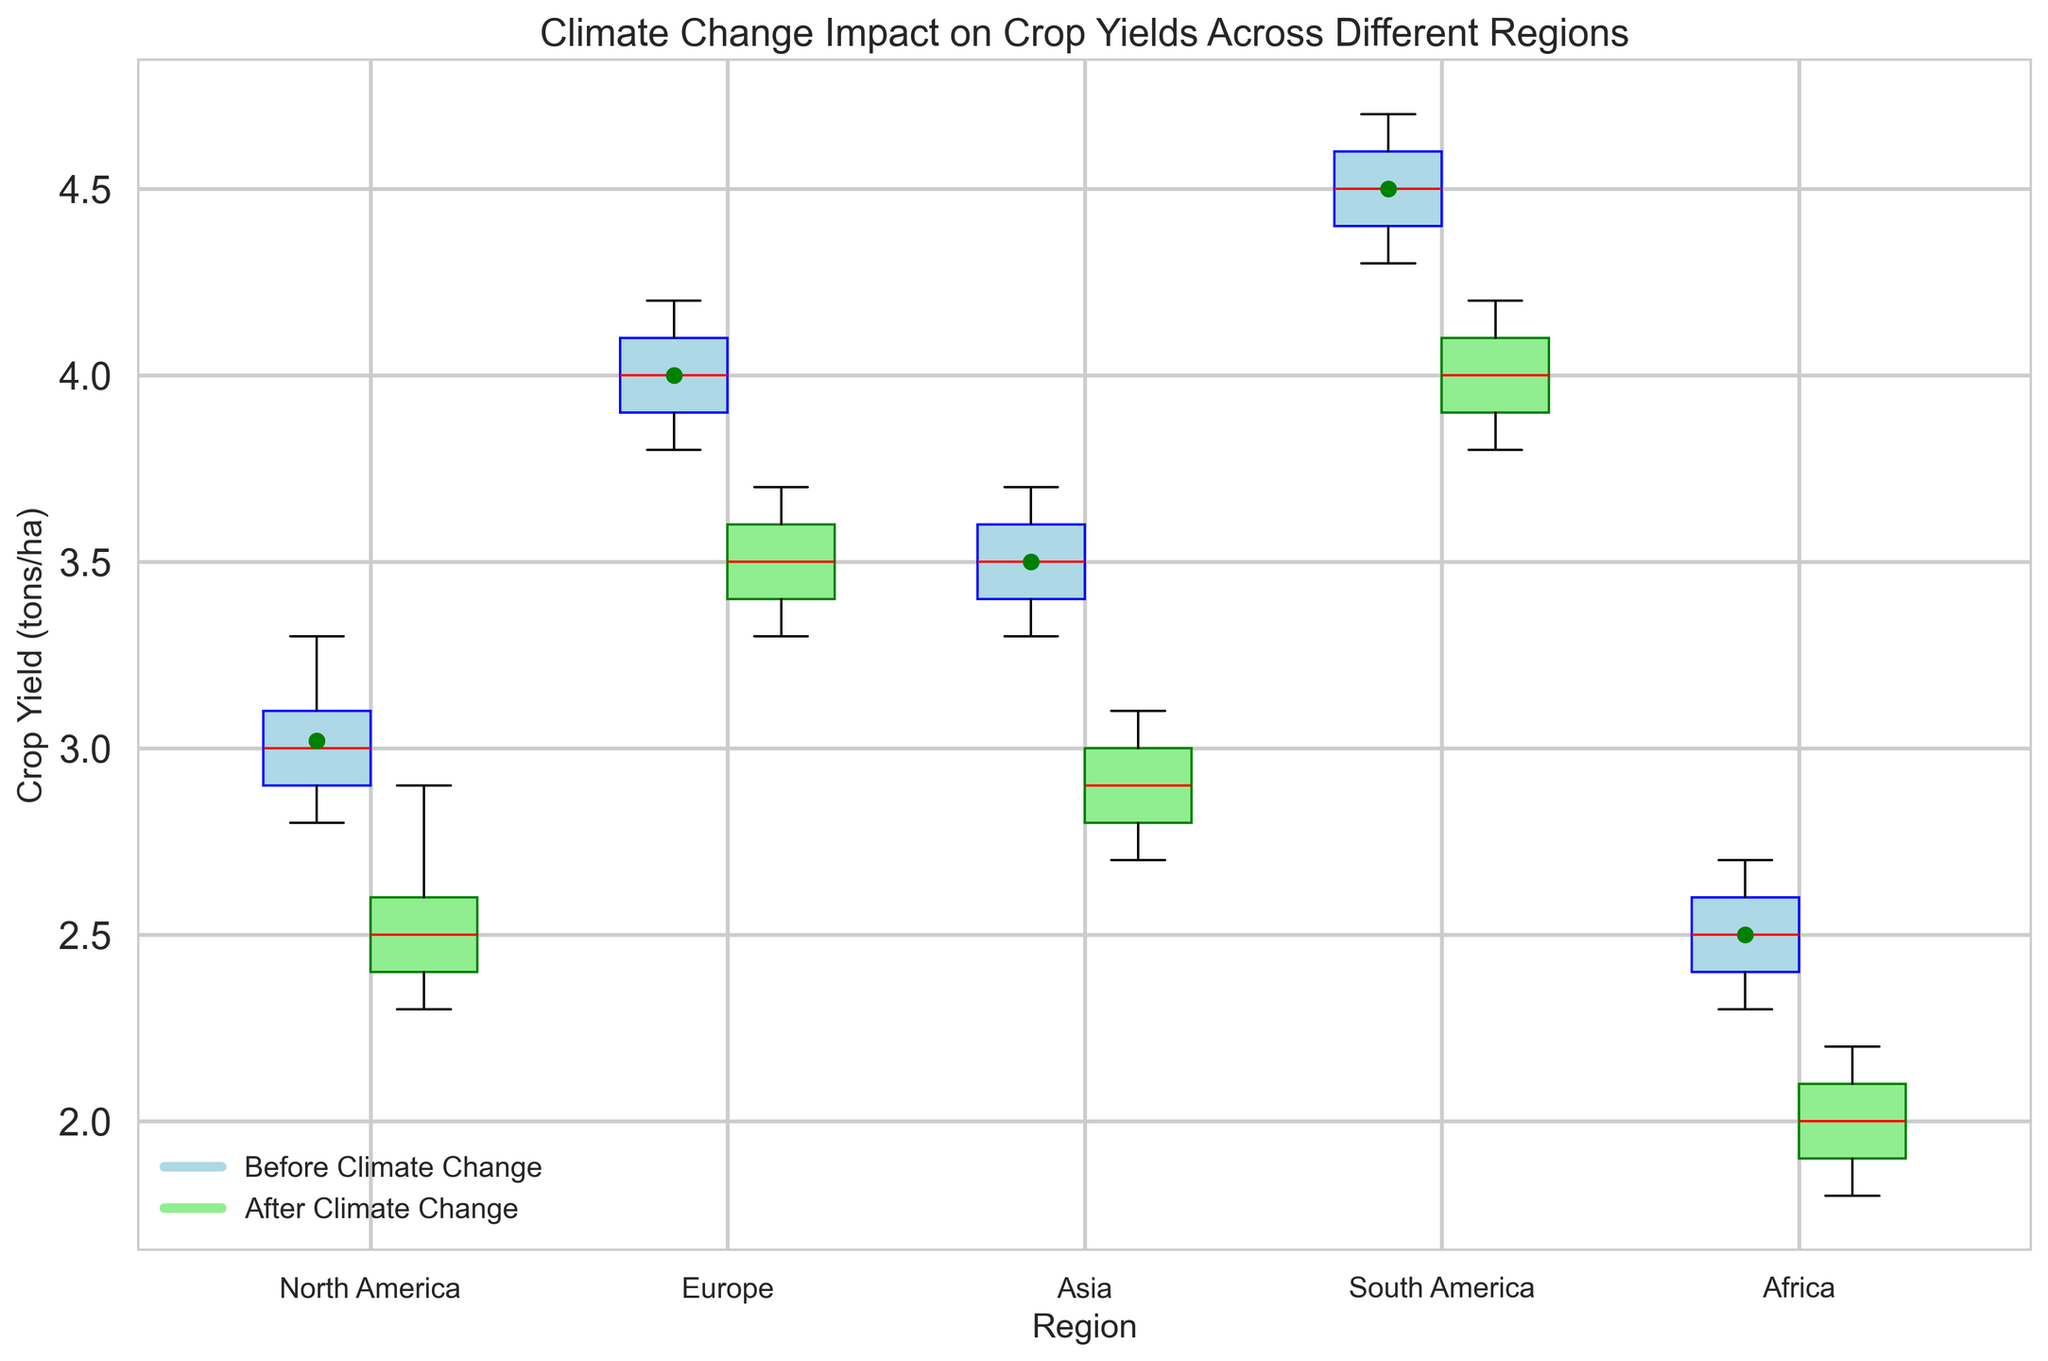What is the median crop yield in North America before and after climate change? To find the median, look at the center of the box plots for North America. The red lines represent the median values.
Answer: Before: 3.0 tons/ha; After: 2.5 tons/ha Which region shows the least reduction in median crop yield after climate change? Compare the position of the red lines (medians) in the box plots before and after climate change for all regions. South America's median changes the least.
Answer: South America What is the mean crop yield in Asia before climate change? The mean is indicated by a green circle in the box plot for Asia before climate change. Identify its value.
Answer: Approximately 3.5 tons/ha Which region has the highest mean crop yield after climate change? The means are marked with yellow crosses. Identify the highest yellow cross among the regions after climate change.
Answer: South America How does the range of crop yields compare between Europe before and after climate change? The range is the difference between the top and bottom whiskers of the box plot. Compare the top and bottom whiskers of Europe's box plots before and after climate change.
Answer: Before: 3.8 to 4.2 (0.4 tons/ha); After: 3.3 to 3.7 (0.4 tons/ha) Which region shows the largest interquartile range (IQR) before climate change? The IQR is the difference between the 75th and 25th percentiles (top and bottom of the box). Compare the height of the boxes for all regions before climate change.
Answer: South America What is the median reduction in crop yield for Africa due to climate change? Subtract the median value (red line) in the “After” box plot from the “Before” box plot for Africa.
Answer: 0.5 tons/ha How does the variability of crop yields change in North America due to climate change? Compare the width and spread (whiskers and interquartile range) of the box plots before and after climate change for North America.
Answer: Variability decreases Which region has the widest range of crop yields after climate change? Identify the longest whiskers in the “After” box plots and compare across the regions.
Answer: North America What color represents the crop yields before climate change in the box plots? Identify the color used for the box plots labeled “Before Climate Change”
Answer: Light blue 